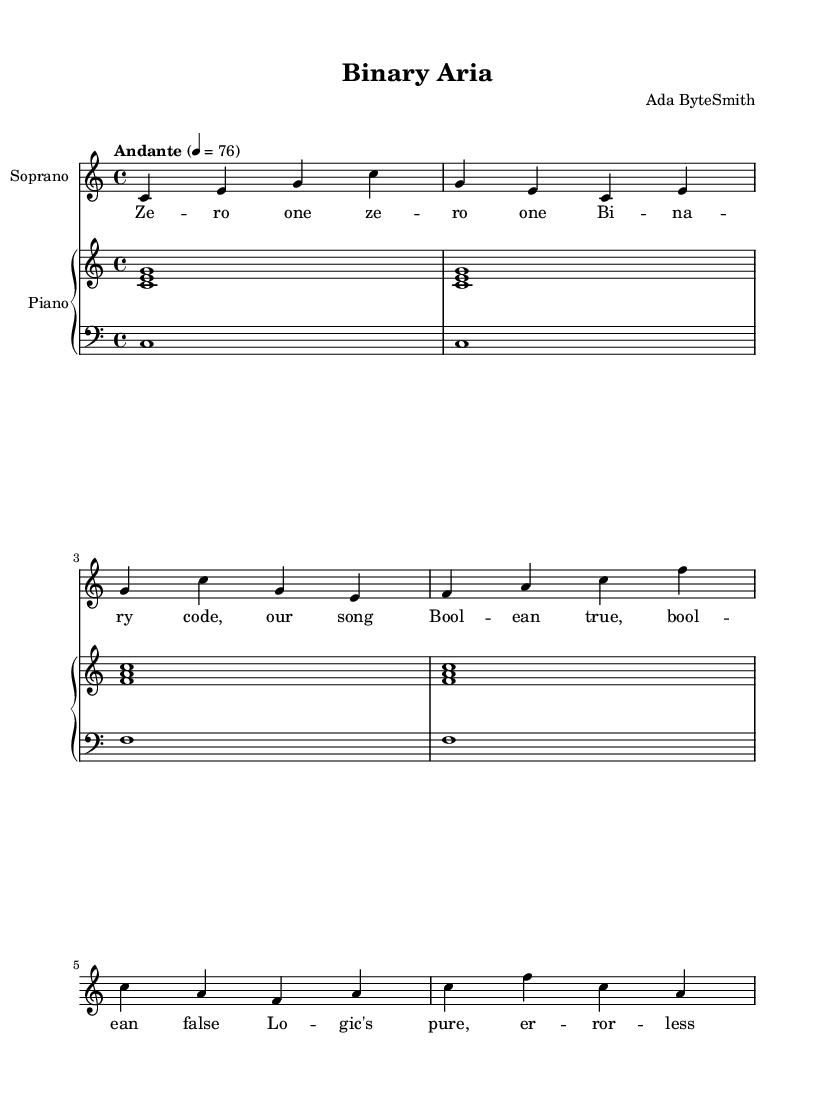What is the key signature of this music? The key signature is C major, which has no sharps or flats.
Answer: C major What is the time signature of this piece? The time signature is indicated at the beginning of the score, and it shows four beats per measure with a quarter note receiving one beat.
Answer: 4/4 What is the tempo marking for the piece? The tempo marking is provided near the beginning, indicating a moderate speed at 76 beats per minute.
Answer: Andante 4 = 76 How many measures are there in the soprano part? Counting the measures in the soprano part, there are a total of four measures in this excerpt.
Answer: 4 Which instrument plays the lowest notes? By examining the clefs used, the bass clef indicates that the piano left hand plays the lowest notes in the score.
Answer: Piano left hand What type of texture does this opera exhibit primarily? Analyzing the interplay of the voice and piano, the texture can be identified as homophonic, where the soprano melody is supported by chordal accompaniment from the piano.
Answer: Homophonic What thematic concept is reflected in the lyrics? The lyrics include references to binary code and Boolean logic, which relate to concepts in computer science, showcasing a theme of minimalism through technological motifs.
Answer: Binary code 